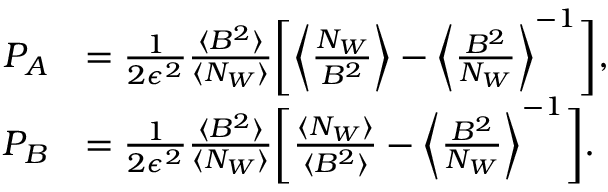Convert formula to latex. <formula><loc_0><loc_0><loc_500><loc_500>\begin{array} { r l } { P _ { A } } & { = \frac { 1 } { 2 \epsilon ^ { 2 } } \frac { \langle B ^ { 2 } \rangle } { \langle N _ { W } \rangle } \left [ \left \langle \frac { N _ { W } } { B ^ { 2 } } \right \rangle - \left \langle \frac { B ^ { 2 } } { N _ { W } } \right \rangle ^ { - 1 } \right ] , } \\ { P _ { B } } & { = \frac { 1 } { 2 \epsilon ^ { 2 } } \frac { \langle B ^ { 2 } \rangle } { \langle N _ { W } \rangle } \left [ \frac { \langle N _ { W } \rangle } { \langle B ^ { 2 } \rangle } - \left \langle \frac { B ^ { 2 } } { N _ { W } } \right \rangle ^ { - 1 } \right ] . } \end{array}</formula> 